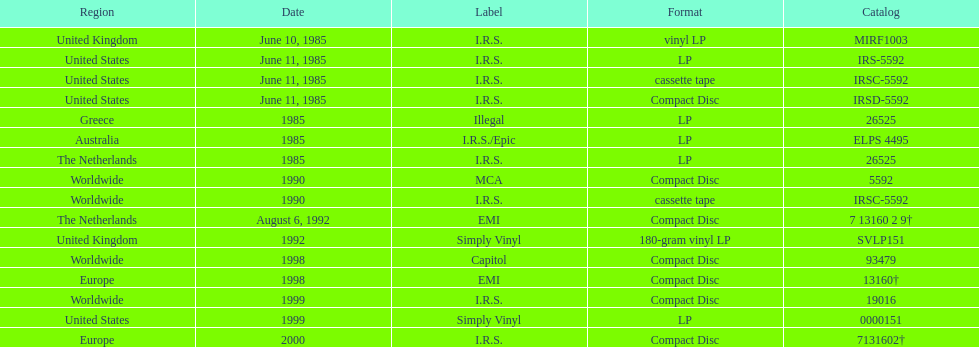What is the largest sequential quantity of releases in lp format? 3. Parse the full table. {'header': ['Region', 'Date', 'Label', 'Format', 'Catalog'], 'rows': [['United Kingdom', 'June 10, 1985', 'I.R.S.', 'vinyl LP', 'MIRF1003'], ['United States', 'June 11, 1985', 'I.R.S.', 'LP', 'IRS-5592'], ['United States', 'June 11, 1985', 'I.R.S.', 'cassette tape', 'IRSC-5592'], ['United States', 'June 11, 1985', 'I.R.S.', 'Compact Disc', 'IRSD-5592'], ['Greece', '1985', 'Illegal', 'LP', '26525'], ['Australia', '1985', 'I.R.S./Epic', 'LP', 'ELPS 4495'], ['The Netherlands', '1985', 'I.R.S.', 'LP', '26525'], ['Worldwide', '1990', 'MCA', 'Compact Disc', '5592'], ['Worldwide', '1990', 'I.R.S.', 'cassette tape', 'IRSC-5592'], ['The Netherlands', 'August 6, 1992', 'EMI', 'Compact Disc', '7 13160 2 9†'], ['United Kingdom', '1992', 'Simply Vinyl', '180-gram vinyl LP', 'SVLP151'], ['Worldwide', '1998', 'Capitol', 'Compact Disc', '93479'], ['Europe', '1998', 'EMI', 'Compact Disc', '13160†'], ['Worldwide', '1999', 'I.R.S.', 'Compact Disc', '19016'], ['United States', '1999', 'Simply Vinyl', 'LP', '0000151'], ['Europe', '2000', 'I.R.S.', 'Compact Disc', '7131602†']]} 